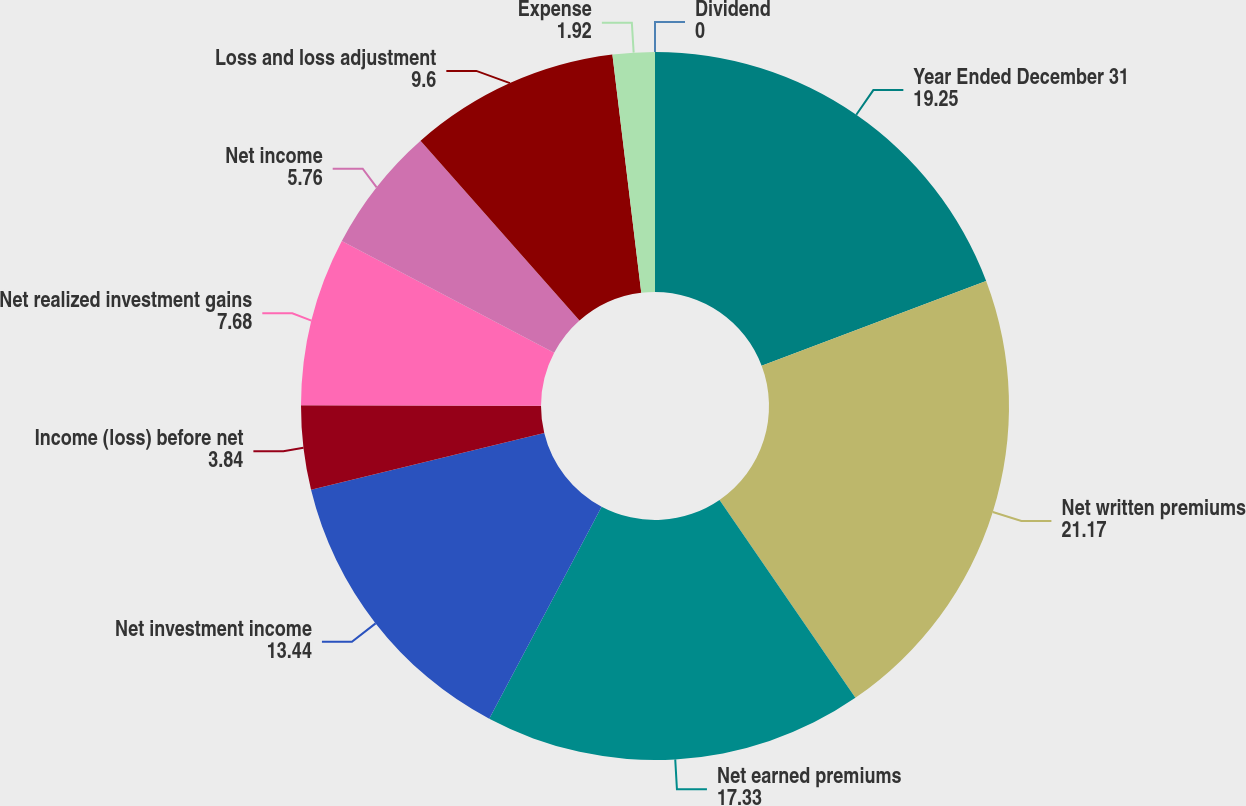Convert chart to OTSL. <chart><loc_0><loc_0><loc_500><loc_500><pie_chart><fcel>Year Ended December 31<fcel>Net written premiums<fcel>Net earned premiums<fcel>Net investment income<fcel>Income (loss) before net<fcel>Net realized investment gains<fcel>Net income<fcel>Loss and loss adjustment<fcel>Expense<fcel>Dividend<nl><fcel>19.25%<fcel>21.17%<fcel>17.33%<fcel>13.44%<fcel>3.84%<fcel>7.68%<fcel>5.76%<fcel>9.6%<fcel>1.92%<fcel>0.0%<nl></chart> 